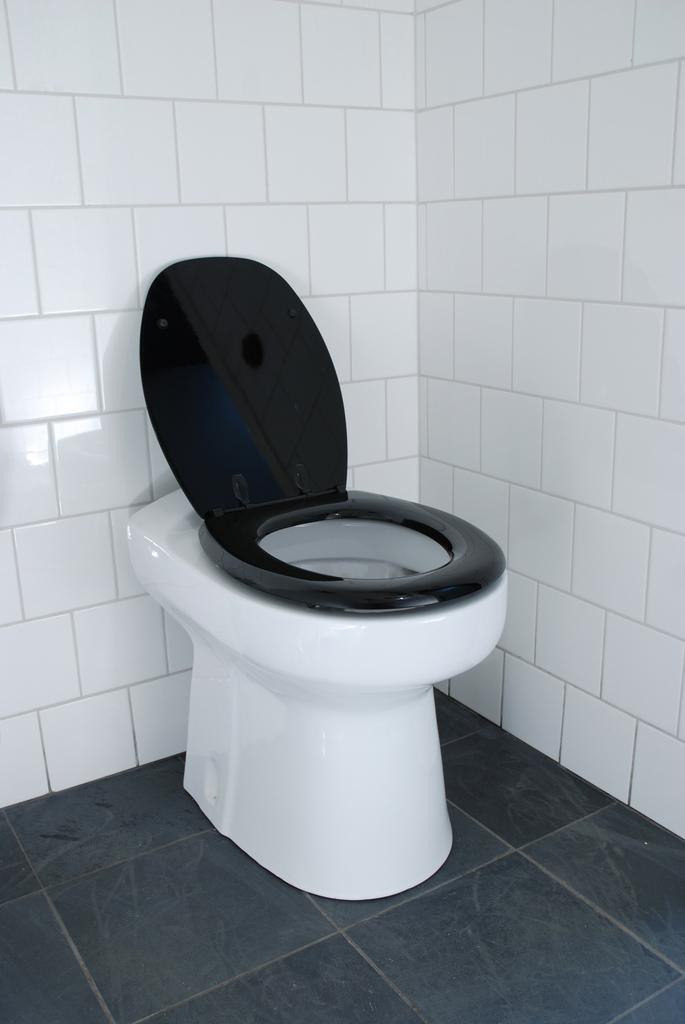What is the main object in the center of the image? There is a toilet basin in the center of the image. What can be seen at the bottom of the image? There is a floor visible at the bottom of the image. What type of club can be seen in the image? There is no club present in the image; it features a toilet basin and a floor. What kind of lace is draped over the toilet basin in the image? There is no lace present in the image; it only shows a toilet basin and a floor. 